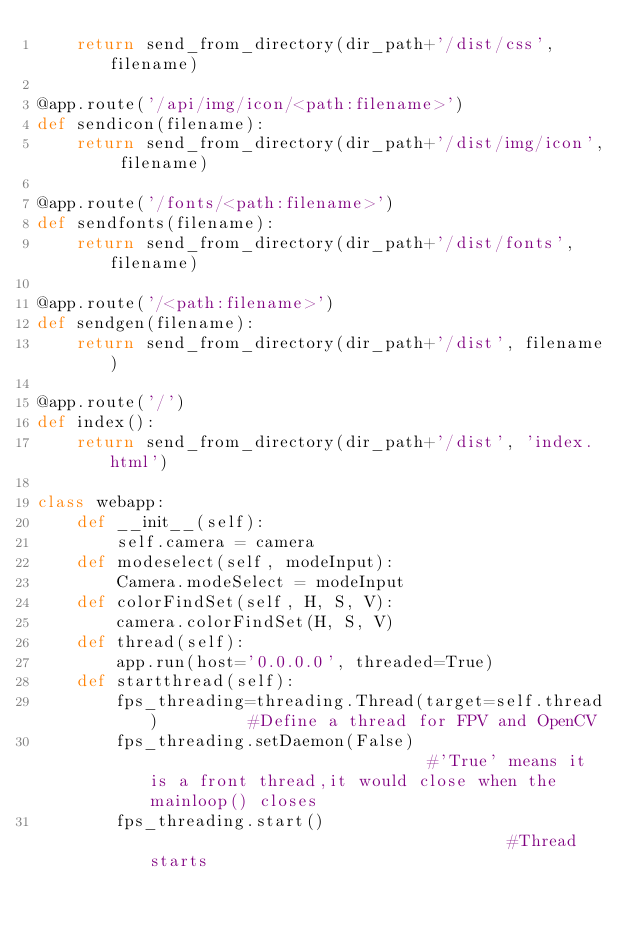Convert code to text. <code><loc_0><loc_0><loc_500><loc_500><_Python_>    return send_from_directory(dir_path+'/dist/css', filename)

@app.route('/api/img/icon/<path:filename>')
def sendicon(filename):
    return send_from_directory(dir_path+'/dist/img/icon', filename)

@app.route('/fonts/<path:filename>')
def sendfonts(filename):
    return send_from_directory(dir_path+'/dist/fonts', filename)

@app.route('/<path:filename>')
def sendgen(filename):
    return send_from_directory(dir_path+'/dist', filename)

@app.route('/')
def index():
    return send_from_directory(dir_path+'/dist', 'index.html')

class webapp:
    def __init__(self):
        self.camera = camera
    def modeselect(self, modeInput):
        Camera.modeSelect = modeInput
    def colorFindSet(self, H, S, V):
        camera.colorFindSet(H, S, V)
    def thread(self):
        app.run(host='0.0.0.0', threaded=True)
    def startthread(self):
        fps_threading=threading.Thread(target=self.thread)         #Define a thread for FPV and OpenCV
        fps_threading.setDaemon(False)                             #'True' means it is a front thread,it would close when the mainloop() closes
        fps_threading.start()                                     #Thread starts

</code> 